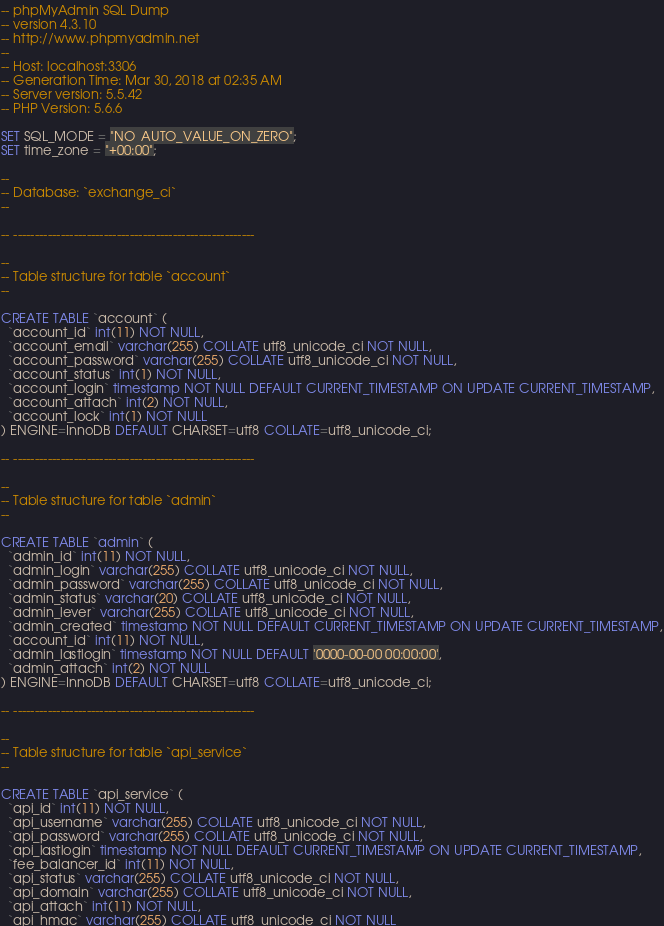Convert code to text. <code><loc_0><loc_0><loc_500><loc_500><_SQL_>-- phpMyAdmin SQL Dump
-- version 4.3.10
-- http://www.phpmyadmin.net
--
-- Host: localhost:3306
-- Generation Time: Mar 30, 2018 at 02:35 AM
-- Server version: 5.5.42
-- PHP Version: 5.6.6

SET SQL_MODE = "NO_AUTO_VALUE_ON_ZERO";
SET time_zone = "+00:00";

--
-- Database: `exchange_ci`
--

-- --------------------------------------------------------

--
-- Table structure for table `account`
--

CREATE TABLE `account` (
  `account_id` int(11) NOT NULL,
  `account_email` varchar(255) COLLATE utf8_unicode_ci NOT NULL,
  `account_password` varchar(255) COLLATE utf8_unicode_ci NOT NULL,
  `account_status` int(1) NOT NULL,
  `account_login` timestamp NOT NULL DEFAULT CURRENT_TIMESTAMP ON UPDATE CURRENT_TIMESTAMP,
  `account_attach` int(2) NOT NULL,
  `account_lock` int(1) NOT NULL
) ENGINE=InnoDB DEFAULT CHARSET=utf8 COLLATE=utf8_unicode_ci;

-- --------------------------------------------------------

--
-- Table structure for table `admin`
--

CREATE TABLE `admin` (
  `admin_id` int(11) NOT NULL,
  `admin_login` varchar(255) COLLATE utf8_unicode_ci NOT NULL,
  `admin_password` varchar(255) COLLATE utf8_unicode_ci NOT NULL,
  `admin_status` varchar(20) COLLATE utf8_unicode_ci NOT NULL,
  `admin_lever` varchar(255) COLLATE utf8_unicode_ci NOT NULL,
  `admin_created` timestamp NOT NULL DEFAULT CURRENT_TIMESTAMP ON UPDATE CURRENT_TIMESTAMP,
  `account_id` int(11) NOT NULL,
  `admin_lastlogin` timestamp NOT NULL DEFAULT '0000-00-00 00:00:00',
  `admin_attach` int(2) NOT NULL
) ENGINE=InnoDB DEFAULT CHARSET=utf8 COLLATE=utf8_unicode_ci;

-- --------------------------------------------------------

--
-- Table structure for table `api_service`
--

CREATE TABLE `api_service` (
  `api_id` int(11) NOT NULL,
  `api_username` varchar(255) COLLATE utf8_unicode_ci NOT NULL,
  `api_password` varchar(255) COLLATE utf8_unicode_ci NOT NULL,
  `api_lastlogin` timestamp NOT NULL DEFAULT CURRENT_TIMESTAMP ON UPDATE CURRENT_TIMESTAMP,
  `fee_balancer_id` int(11) NOT NULL,
  `api_status` varchar(255) COLLATE utf8_unicode_ci NOT NULL,
  `api_domain` varchar(255) COLLATE utf8_unicode_ci NOT NULL,
  `api_attach` int(11) NOT NULL,
  `api_hmac` varchar(255) COLLATE utf8_unicode_ci NOT NULL</code> 